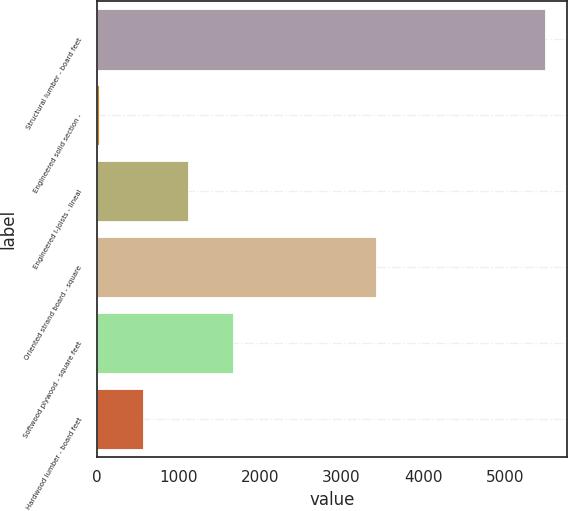Convert chart to OTSL. <chart><loc_0><loc_0><loc_500><loc_500><bar_chart><fcel>Structural lumber - board feet<fcel>Engineered solid section -<fcel>Engineered I-joists - lineal<fcel>Oriented strand board - square<fcel>Softwood plywood - square feet<fcel>Hardwood lumber - board feet<nl><fcel>5490<fcel>28<fcel>1120.4<fcel>3428<fcel>1666.6<fcel>574.2<nl></chart> 